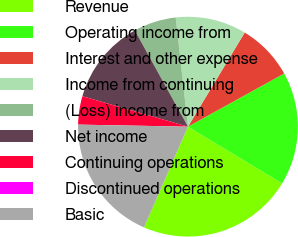<chart> <loc_0><loc_0><loc_500><loc_500><pie_chart><fcel>Revenue<fcel>Operating income from<fcel>Interest and other expense<fcel>Income from continuing<fcel>(Loss) income from<fcel>Net income<fcel>Continuing operations<fcel>Discontinued operations<fcel>Basic<nl><fcel>22.92%<fcel>16.67%<fcel>8.33%<fcel>10.42%<fcel>6.25%<fcel>12.5%<fcel>4.17%<fcel>0.0%<fcel>18.75%<nl></chart> 